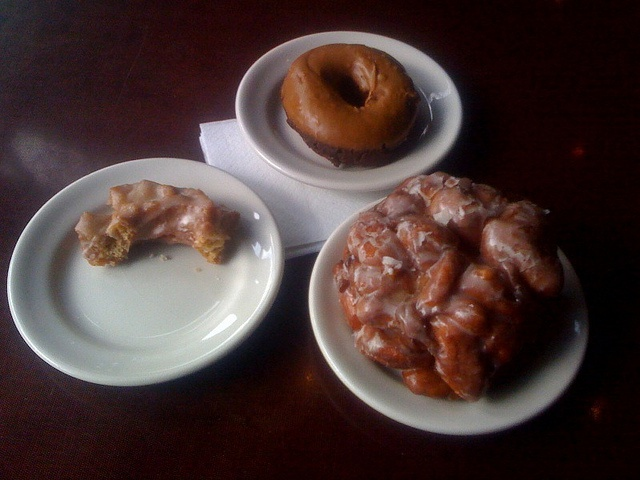Describe the objects in this image and their specific colors. I can see dining table in black, darkgray, maroon, and gray tones, donut in black, maroon, and brown tones, donut in black, maroon, and brown tones, and donut in black, gray, maroon, and brown tones in this image. 